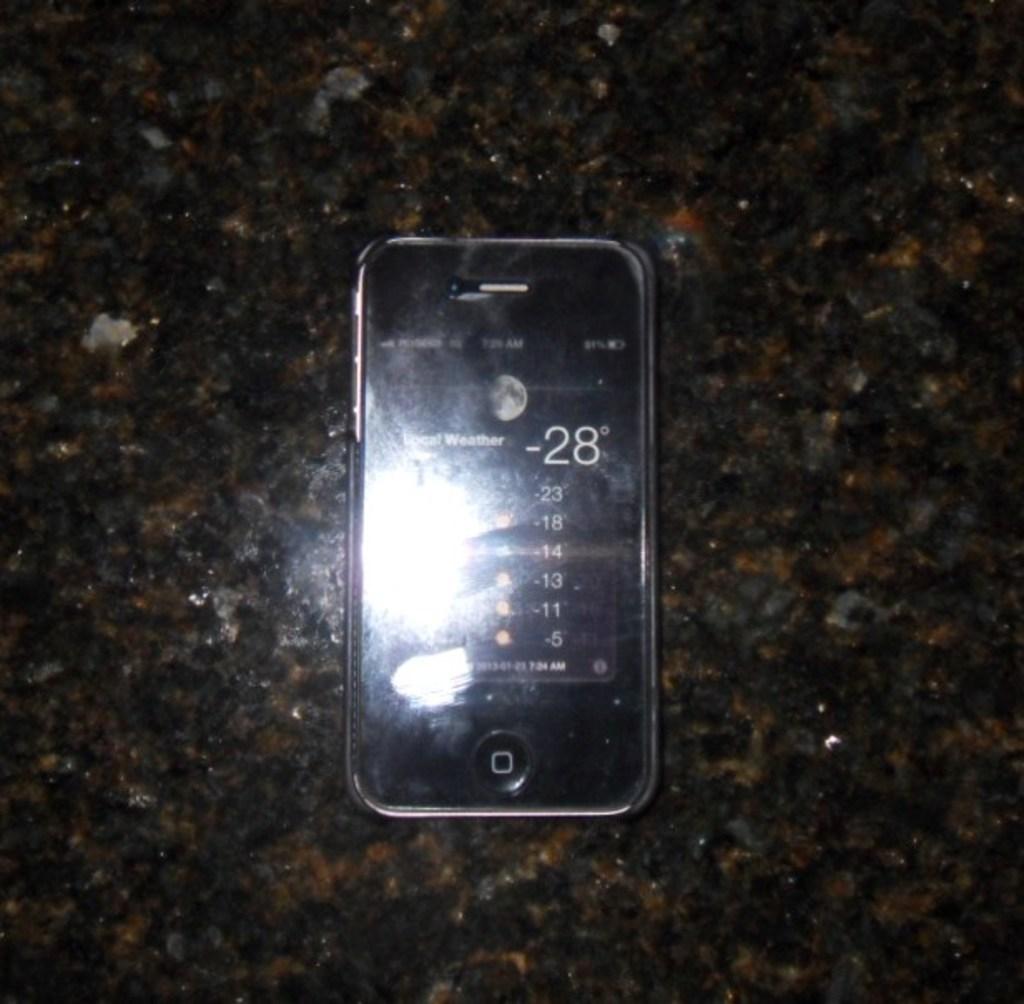How cold is it?
Your answer should be very brief. -28. 